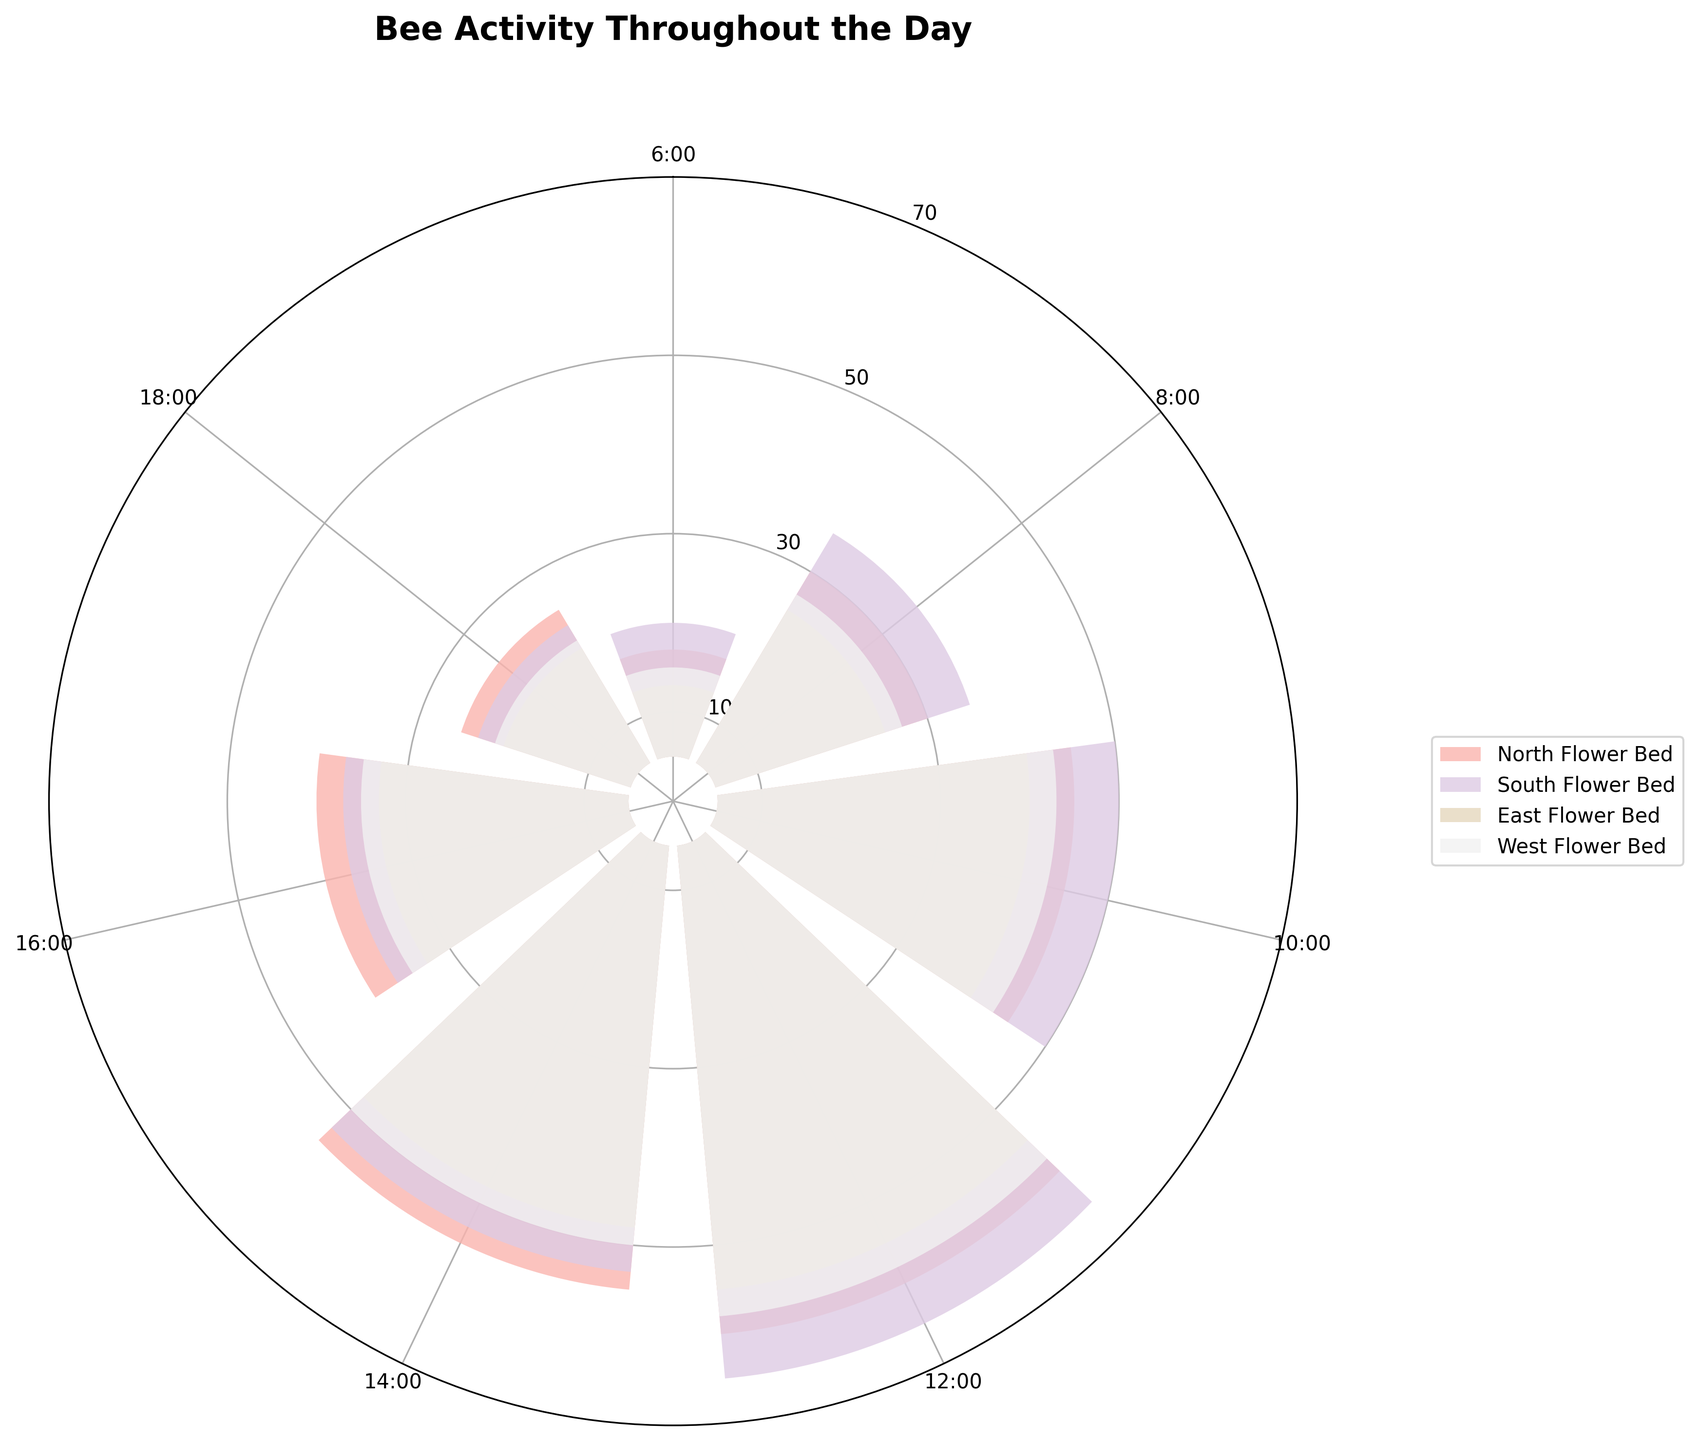How many sections are there in the garden? The legend displays the different sections in the garden, which are North Flower Bed, South Flower Bed, East Flower Bed, and West Flower Bed.
Answer: 4 At what time do bees show the highest activity in the West Flower Bed? By observing the lengths of the bars in the West Flower Bed section over the different times, you can see that the bar is longest at 12:00.
Answer: 12:00 Which section has the lowest bee activity at 6:00? By comparing the lengths of the bars at the 6:00 tick, it is clear that the East Flower Bed has the shortest bar.
Answer: East Flower Bed How does the bee activity in the South Flower Bed at 10:00 compare to the activity in the North Flower Bed at the same time? At 10:00, the bars show that the South Flower Bed has slightly higher bee activity than the North Flower Bed.
Answer: South Flower Bed has higher activity What is the combined bee count in all sections at 14:00? Sum the values for all sections at 14:00: 50 (North) + 48 (South) + 43 (East) + 45 (West) = 186.
Answer: 186 Which section shows a continuous decrease in bee activity from 12:00 to 18:00? By observing the trend from 12:00 to 18:00, the South Flower Bed shows continuous decline: from 60 (12:00) to 48 (14:00) to 32 (16:00) to 18 (18:00).
Answer: South Flower Bed Between 8:00 and 10:00, which section sees the largest increase in bee count? Find the difference in bee activity between 8:00 and 10:00 for each section: North (15), South (15), East (15), and West (16). The West Flower Bed sees the largest increase.
Answer: West Flower Bed What is the median bee count in all sections at 8:00? List the counts at 8:00 for all sections (25, 30, 20, 22) and arrange them in order (20, 22, 25, 30). The median is (22 + 25) / 2 = 23.5.
Answer: 23.5 